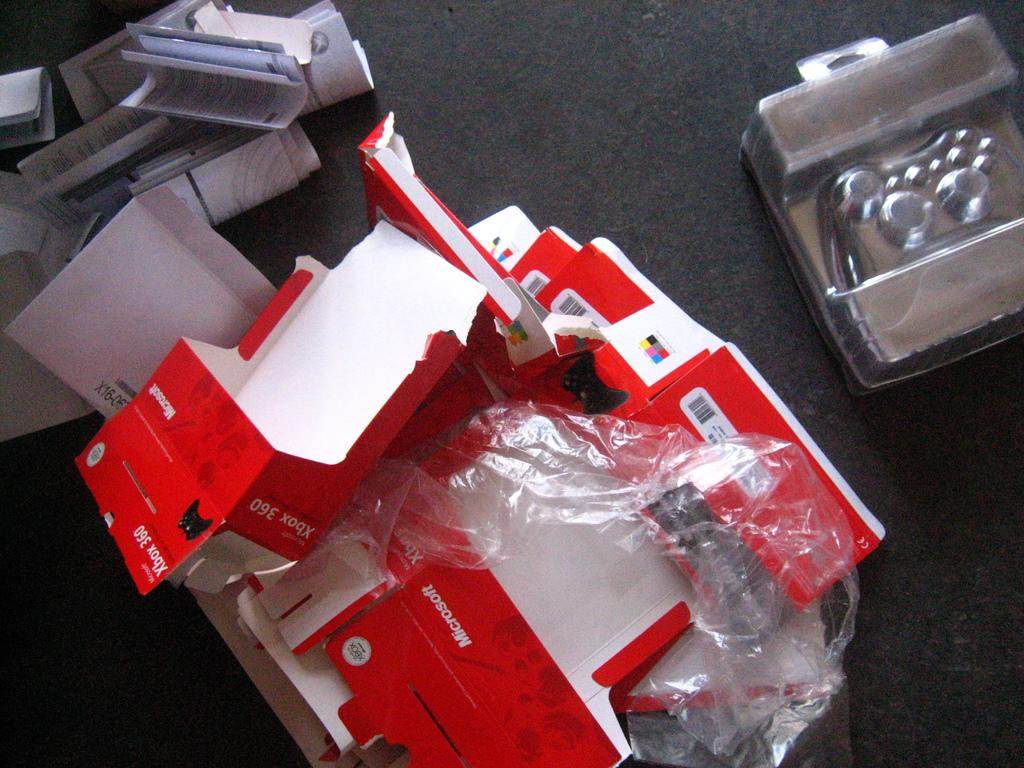What type of objects can be seen in the image? There are papers in the image. Can you describe the surface on which the objects are placed? The objects are placed on a black surface in the image. What other objects, besides papers, can be seen on the black surface? Unfortunately, the provided facts do not specify any other objects on the black surface. How many snails can be seen crawling on the papers in the image? There are no snails present in the image. What season is depicted in the image? The provided facts do not indicate any seasonal context in the image. 